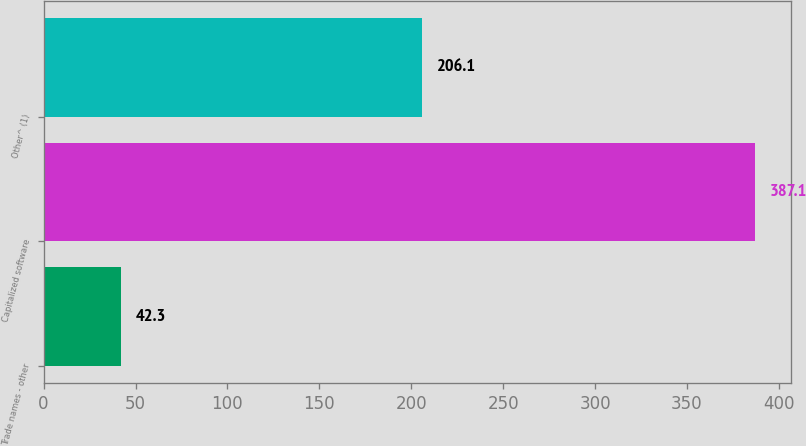Convert chart. <chart><loc_0><loc_0><loc_500><loc_500><bar_chart><fcel>Trade names - other<fcel>Capitalized software<fcel>Other^ (1)<nl><fcel>42.3<fcel>387.1<fcel>206.1<nl></chart> 